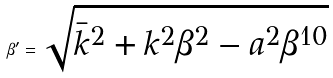Convert formula to latex. <formula><loc_0><loc_0><loc_500><loc_500>\beta ^ { \prime } = \sqrt { \bar { k } ^ { 2 } + k ^ { 2 } \beta ^ { 2 } - a ^ { 2 } \beta ^ { 1 0 } }</formula> 